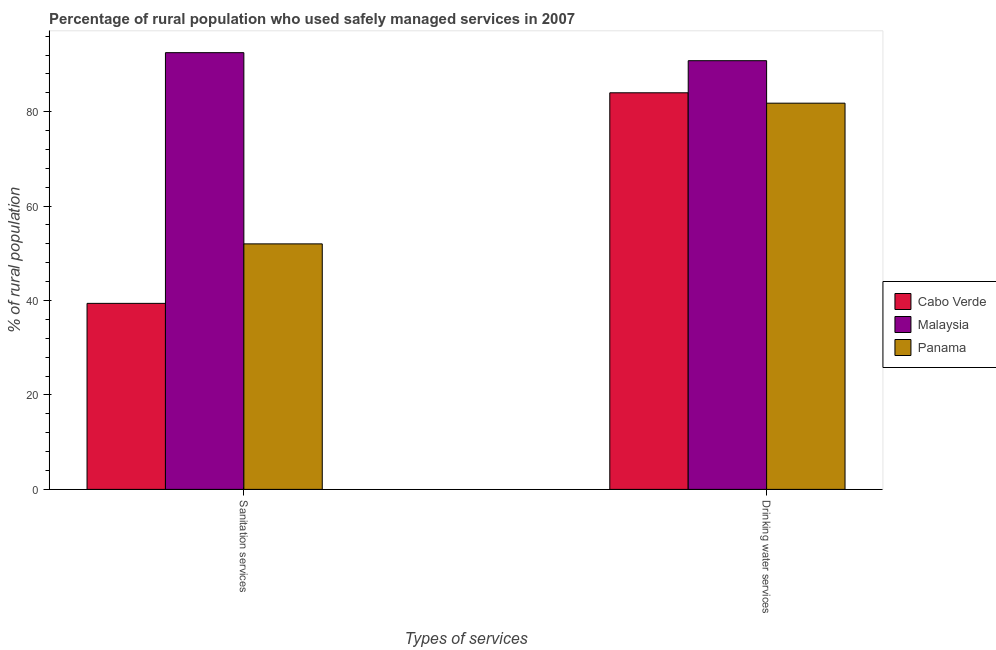How many different coloured bars are there?
Ensure brevity in your answer.  3. Are the number of bars per tick equal to the number of legend labels?
Provide a short and direct response. Yes. What is the label of the 2nd group of bars from the left?
Your answer should be compact. Drinking water services. Across all countries, what is the maximum percentage of rural population who used sanitation services?
Give a very brief answer. 92.5. Across all countries, what is the minimum percentage of rural population who used drinking water services?
Give a very brief answer. 81.8. In which country was the percentage of rural population who used drinking water services maximum?
Ensure brevity in your answer.  Malaysia. In which country was the percentage of rural population who used sanitation services minimum?
Provide a succinct answer. Cabo Verde. What is the total percentage of rural population who used sanitation services in the graph?
Give a very brief answer. 183.9. What is the difference between the percentage of rural population who used sanitation services in Cabo Verde and that in Panama?
Keep it short and to the point. -12.6. What is the difference between the percentage of rural population who used sanitation services in Panama and the percentage of rural population who used drinking water services in Malaysia?
Ensure brevity in your answer.  -38.8. What is the average percentage of rural population who used sanitation services per country?
Keep it short and to the point. 61.3. What is the difference between the percentage of rural population who used sanitation services and percentage of rural population who used drinking water services in Cabo Verde?
Keep it short and to the point. -44.6. In how many countries, is the percentage of rural population who used sanitation services greater than 52 %?
Keep it short and to the point. 1. What is the ratio of the percentage of rural population who used drinking water services in Malaysia to that in Panama?
Provide a succinct answer. 1.11. What does the 1st bar from the left in Sanitation services represents?
Offer a very short reply. Cabo Verde. What does the 1st bar from the right in Sanitation services represents?
Your answer should be compact. Panama. How many bars are there?
Your response must be concise. 6. Are all the bars in the graph horizontal?
Your answer should be compact. No. How many countries are there in the graph?
Ensure brevity in your answer.  3. What is the difference between two consecutive major ticks on the Y-axis?
Offer a very short reply. 20. Does the graph contain any zero values?
Your answer should be very brief. No. How many legend labels are there?
Your answer should be compact. 3. How are the legend labels stacked?
Provide a succinct answer. Vertical. What is the title of the graph?
Offer a very short reply. Percentage of rural population who used safely managed services in 2007. What is the label or title of the X-axis?
Make the answer very short. Types of services. What is the label or title of the Y-axis?
Give a very brief answer. % of rural population. What is the % of rural population of Cabo Verde in Sanitation services?
Your answer should be very brief. 39.4. What is the % of rural population in Malaysia in Sanitation services?
Ensure brevity in your answer.  92.5. What is the % of rural population of Malaysia in Drinking water services?
Offer a very short reply. 90.8. What is the % of rural population of Panama in Drinking water services?
Provide a succinct answer. 81.8. Across all Types of services, what is the maximum % of rural population of Cabo Verde?
Your answer should be compact. 84. Across all Types of services, what is the maximum % of rural population in Malaysia?
Ensure brevity in your answer.  92.5. Across all Types of services, what is the maximum % of rural population of Panama?
Provide a succinct answer. 81.8. Across all Types of services, what is the minimum % of rural population in Cabo Verde?
Give a very brief answer. 39.4. Across all Types of services, what is the minimum % of rural population in Malaysia?
Ensure brevity in your answer.  90.8. What is the total % of rural population of Cabo Verde in the graph?
Give a very brief answer. 123.4. What is the total % of rural population of Malaysia in the graph?
Give a very brief answer. 183.3. What is the total % of rural population in Panama in the graph?
Provide a succinct answer. 133.8. What is the difference between the % of rural population of Cabo Verde in Sanitation services and that in Drinking water services?
Offer a terse response. -44.6. What is the difference between the % of rural population of Panama in Sanitation services and that in Drinking water services?
Offer a very short reply. -29.8. What is the difference between the % of rural population in Cabo Verde in Sanitation services and the % of rural population in Malaysia in Drinking water services?
Your answer should be compact. -51.4. What is the difference between the % of rural population of Cabo Verde in Sanitation services and the % of rural population of Panama in Drinking water services?
Make the answer very short. -42.4. What is the average % of rural population of Cabo Verde per Types of services?
Keep it short and to the point. 61.7. What is the average % of rural population of Malaysia per Types of services?
Give a very brief answer. 91.65. What is the average % of rural population in Panama per Types of services?
Offer a very short reply. 66.9. What is the difference between the % of rural population of Cabo Verde and % of rural population of Malaysia in Sanitation services?
Your response must be concise. -53.1. What is the difference between the % of rural population of Cabo Verde and % of rural population of Panama in Sanitation services?
Give a very brief answer. -12.6. What is the difference between the % of rural population in Malaysia and % of rural population in Panama in Sanitation services?
Offer a very short reply. 40.5. What is the difference between the % of rural population in Cabo Verde and % of rural population in Malaysia in Drinking water services?
Give a very brief answer. -6.8. What is the ratio of the % of rural population of Cabo Verde in Sanitation services to that in Drinking water services?
Your answer should be very brief. 0.47. What is the ratio of the % of rural population of Malaysia in Sanitation services to that in Drinking water services?
Your answer should be compact. 1.02. What is the ratio of the % of rural population of Panama in Sanitation services to that in Drinking water services?
Make the answer very short. 0.64. What is the difference between the highest and the second highest % of rural population of Cabo Verde?
Offer a very short reply. 44.6. What is the difference between the highest and the second highest % of rural population in Panama?
Ensure brevity in your answer.  29.8. What is the difference between the highest and the lowest % of rural population in Cabo Verde?
Give a very brief answer. 44.6. What is the difference between the highest and the lowest % of rural population in Panama?
Provide a succinct answer. 29.8. 